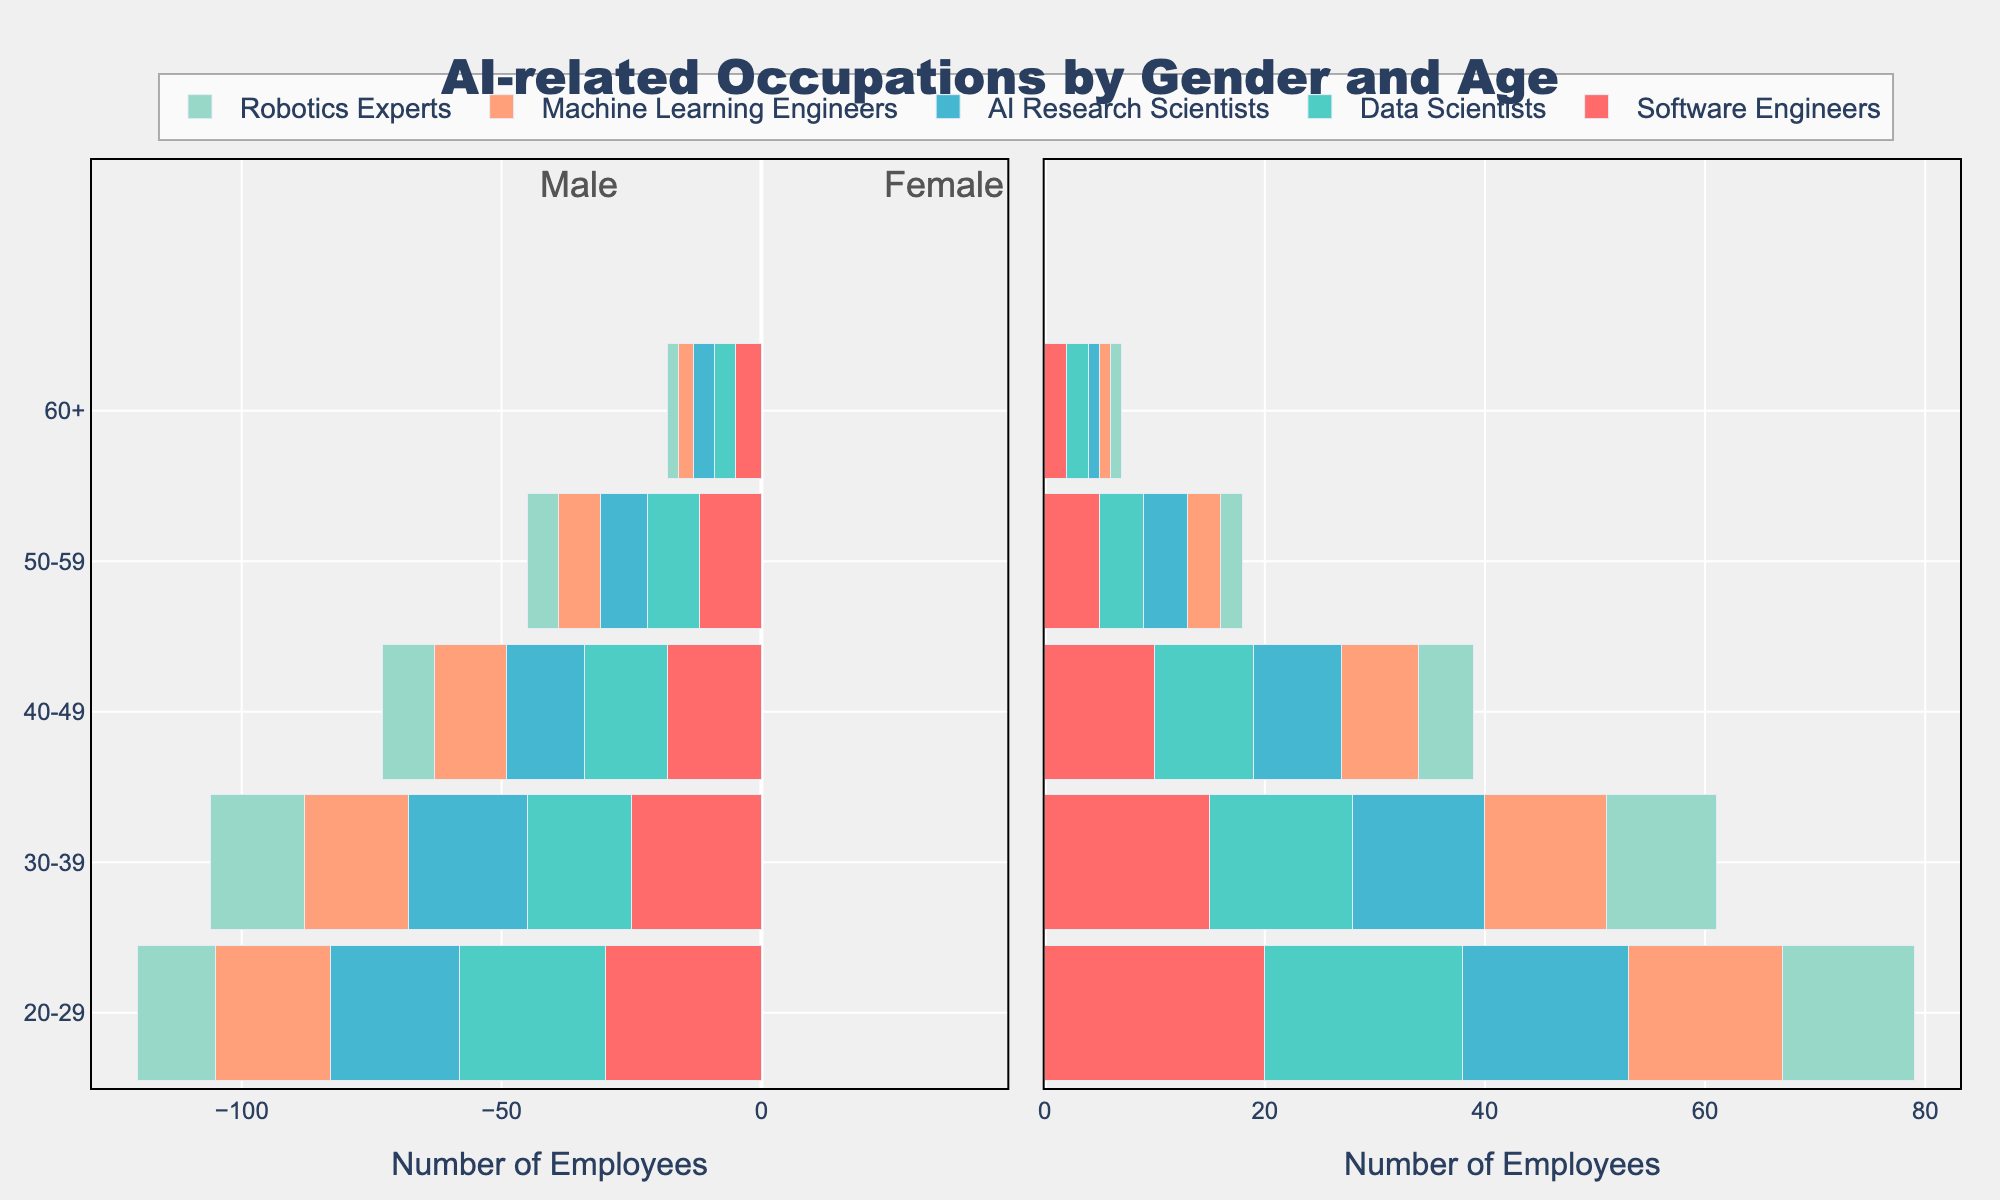What is the age group with the highest number of male Data Scientists? By looking at the left subplot of the diverging bar chart and focusing on the bar segment related to Data Scientists, we see that the 20-29 age group has the longest length in negative direction.
Answer: 20-29 How many male AI Research Scientists are there in the 30-39 age group and the 50-59 age group combined? According to the data, the number of male AI Research Scientists in the 30-39 age group is 23, and in the 50-59 age group is 9. Adding them together, the total is 23 + 9.
Answer: 32 Who dominates the Machine Learning Engineers occupation in the 20-29 age group, males or females? The bar for male Machine Learning Engineers (22) in the 20-29 age group is longer than that for females (14). Hence, males dominate this occupation.
Answer: Males How many more male Software Engineers are there compared to females in the 40-49 age group? There are 18 male Software Engineers and 10 female Software Engineers in the 40-49 age group. The difference is 18 - 10.
Answer: 8 Which gender has a higher total number of employees in the 60+ age group across all occupations? Summing the male counts (5+4+4+3+2=18) and female counts (2+2+1+1+1=7) in the 60+ age group shows that the total for males is higher.
Answer: Males For the 30-39 age group, which occupation has the fewest number of male employees? Looking at the male bars for the 30-39 age group in the left subplot, Robotics Experts have the shortest bar with 18 employees.
Answer: Robotics Experts Compare the number of male and female Robotics Experts in the 20-29 age group. The male Robotics Experts (15) bar for 20-29 age group is longer than the female Robotics Experts (12) bar.
Answer: Males have more What is the combined total of male and female Machine Learning Engineers in the 40-49 age group? Adding the number of male (14) and female (7) Machine Learning Engineers in the 40-49 age group, the total is 14 + 7.
Answer: 21 Which occupation has the smallest gender gap in the 50-59 age group? Comparing the differences for each occupation in the 50-59 age group, we see that both males and females have equal counts (2) for Robotics Experts.
Answer: Robotics Experts In the 20-29 age group, which occupation shows the least difference in the number of employees between males and females? Evaluating the bar lengths for 20-29 age group, the difference in Data Scientists (30 males, 28 females) is the smallest, being 2.
Answer: Data Scientists 